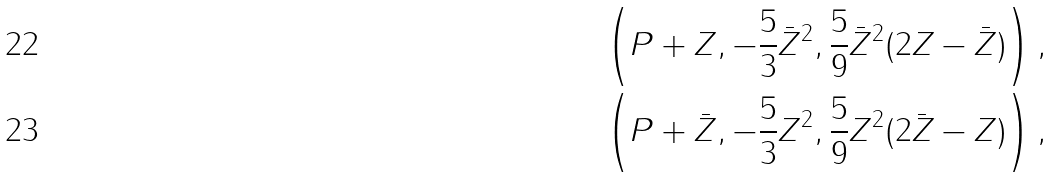<formula> <loc_0><loc_0><loc_500><loc_500>& \left ( P + Z , - \frac { 5 } { 3 } \bar { Z } ^ { 2 } , \frac { 5 } { 9 } \bar { Z } ^ { 2 } ( 2 Z - \bar { Z } ) \right ) , \\ & \left ( P + \bar { Z } , - \frac { 5 } { 3 } Z ^ { 2 } , \frac { 5 } { 9 } Z ^ { 2 } ( 2 \bar { Z } - Z ) \right ) ,</formula> 